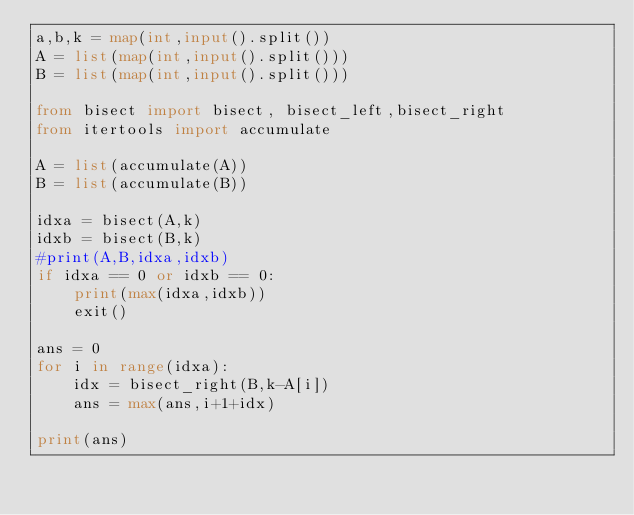Convert code to text. <code><loc_0><loc_0><loc_500><loc_500><_Python_>a,b,k = map(int,input().split())
A = list(map(int,input().split()))
B = list(map(int,input().split()))

from bisect import bisect, bisect_left,bisect_right
from itertools import accumulate

A = list(accumulate(A))
B = list(accumulate(B))

idxa = bisect(A,k)
idxb = bisect(B,k)
#print(A,B,idxa,idxb)
if idxa == 0 or idxb == 0:
    print(max(idxa,idxb))
    exit()
    
ans = 0  
for i in range(idxa):
    idx = bisect_right(B,k-A[i])
    ans = max(ans,i+1+idx)
    
print(ans)</code> 